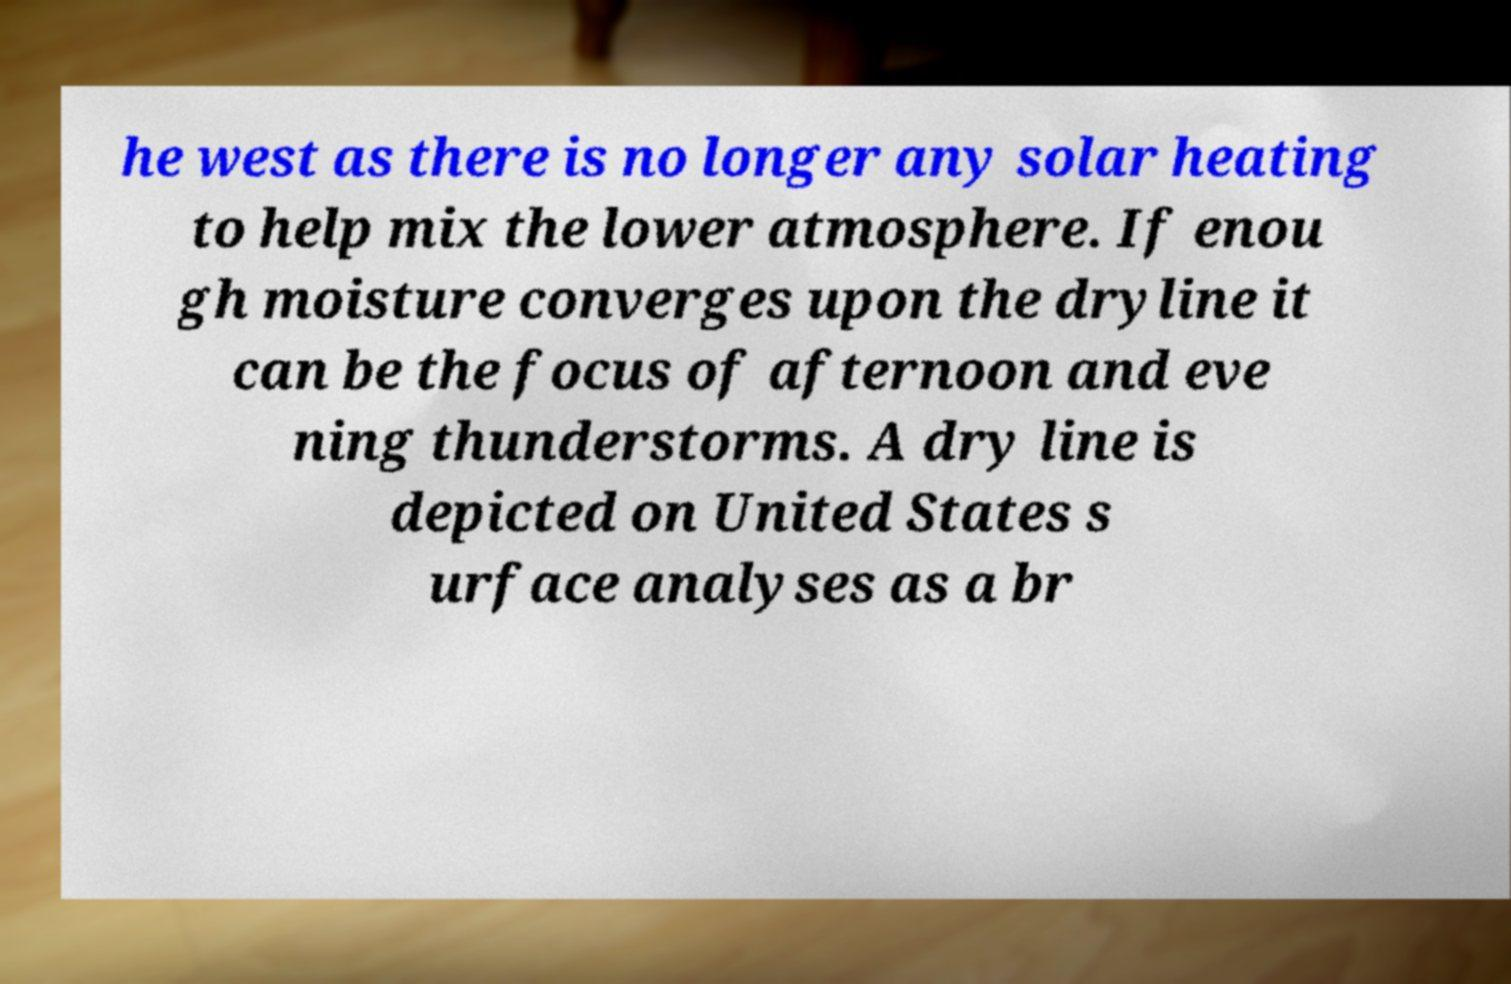Please read and relay the text visible in this image. What does it say? he west as there is no longer any solar heating to help mix the lower atmosphere. If enou gh moisture converges upon the dryline it can be the focus of afternoon and eve ning thunderstorms. A dry line is depicted on United States s urface analyses as a br 